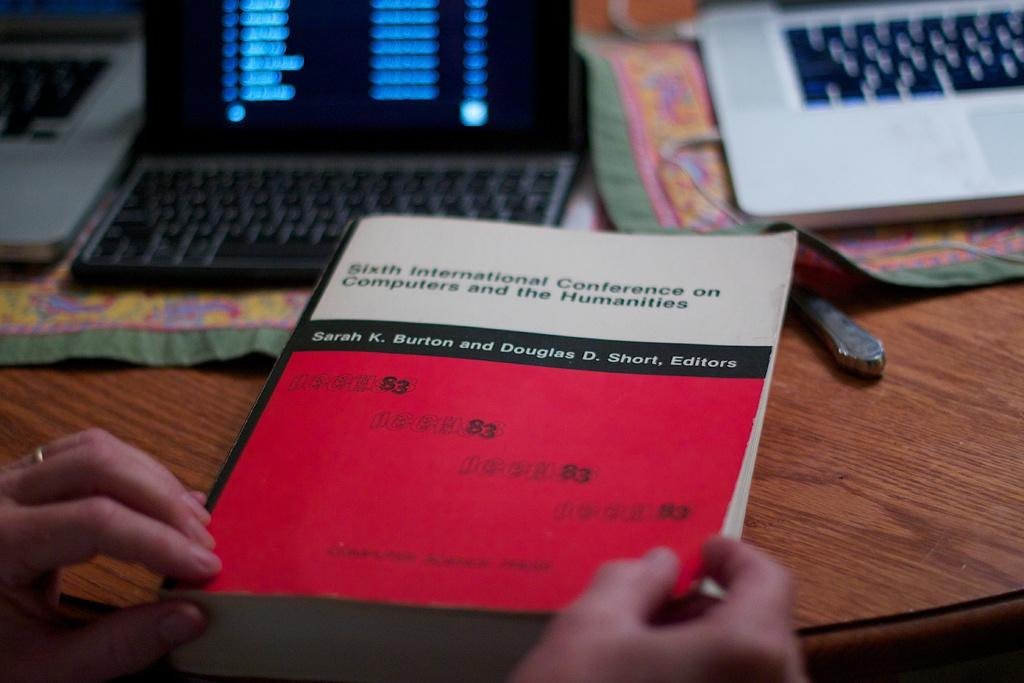Provide a one-sentence caption for the provided image. A person is holding a book about the sixth international conference on computers and the humanities. 